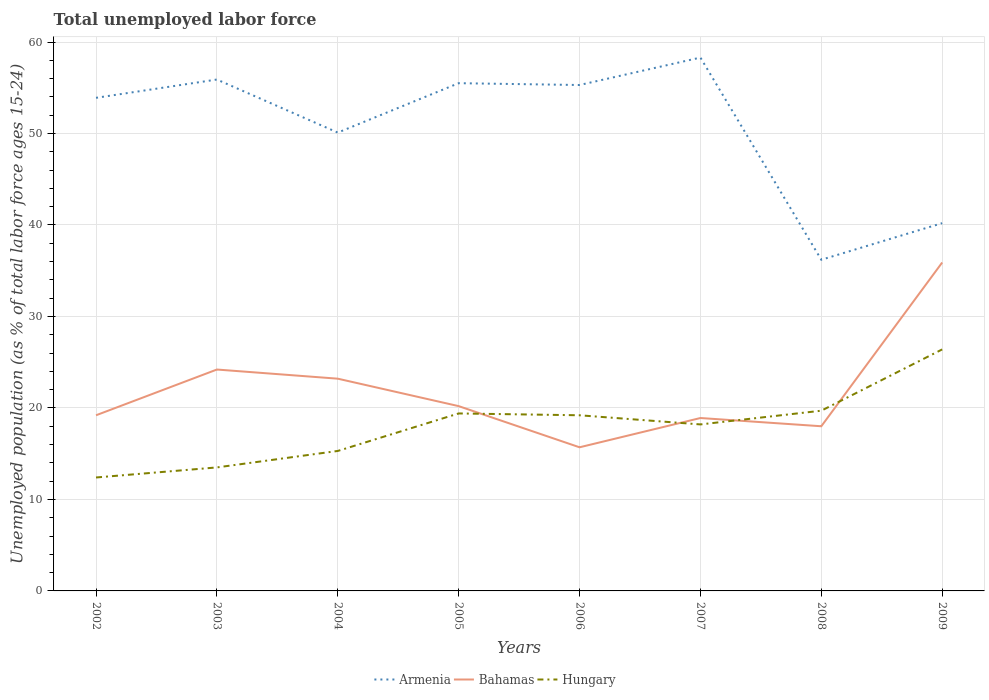Does the line corresponding to Armenia intersect with the line corresponding to Bahamas?
Keep it short and to the point. No. Is the number of lines equal to the number of legend labels?
Your answer should be very brief. Yes. Across all years, what is the maximum percentage of unemployed population in in Armenia?
Provide a succinct answer. 36.2. In which year was the percentage of unemployed population in in Bahamas maximum?
Offer a terse response. 2006. What is the total percentage of unemployed population in in Armenia in the graph?
Provide a succinct answer. -2.8. What is the difference between the highest and the second highest percentage of unemployed population in in Bahamas?
Make the answer very short. 20.2. Is the percentage of unemployed population in in Hungary strictly greater than the percentage of unemployed population in in Armenia over the years?
Make the answer very short. Yes. How many lines are there?
Your answer should be very brief. 3. What is the difference between two consecutive major ticks on the Y-axis?
Your answer should be compact. 10. Are the values on the major ticks of Y-axis written in scientific E-notation?
Offer a terse response. No. Does the graph contain any zero values?
Your answer should be very brief. No. Does the graph contain grids?
Your answer should be very brief. Yes. Where does the legend appear in the graph?
Provide a succinct answer. Bottom center. What is the title of the graph?
Your answer should be very brief. Total unemployed labor force. Does "Estonia" appear as one of the legend labels in the graph?
Provide a succinct answer. No. What is the label or title of the Y-axis?
Keep it short and to the point. Unemployed population (as % of total labor force ages 15-24). What is the Unemployed population (as % of total labor force ages 15-24) in Armenia in 2002?
Offer a very short reply. 53.9. What is the Unemployed population (as % of total labor force ages 15-24) of Bahamas in 2002?
Give a very brief answer. 19.2. What is the Unemployed population (as % of total labor force ages 15-24) in Hungary in 2002?
Ensure brevity in your answer.  12.4. What is the Unemployed population (as % of total labor force ages 15-24) of Armenia in 2003?
Keep it short and to the point. 55.9. What is the Unemployed population (as % of total labor force ages 15-24) in Bahamas in 2003?
Give a very brief answer. 24.2. What is the Unemployed population (as % of total labor force ages 15-24) of Hungary in 2003?
Provide a short and direct response. 13.5. What is the Unemployed population (as % of total labor force ages 15-24) in Armenia in 2004?
Provide a succinct answer. 50.1. What is the Unemployed population (as % of total labor force ages 15-24) of Bahamas in 2004?
Offer a terse response. 23.2. What is the Unemployed population (as % of total labor force ages 15-24) of Hungary in 2004?
Your response must be concise. 15.3. What is the Unemployed population (as % of total labor force ages 15-24) in Armenia in 2005?
Make the answer very short. 55.5. What is the Unemployed population (as % of total labor force ages 15-24) of Bahamas in 2005?
Your answer should be compact. 20.2. What is the Unemployed population (as % of total labor force ages 15-24) in Hungary in 2005?
Your answer should be very brief. 19.4. What is the Unemployed population (as % of total labor force ages 15-24) in Armenia in 2006?
Keep it short and to the point. 55.3. What is the Unemployed population (as % of total labor force ages 15-24) in Bahamas in 2006?
Provide a succinct answer. 15.7. What is the Unemployed population (as % of total labor force ages 15-24) in Hungary in 2006?
Provide a short and direct response. 19.2. What is the Unemployed population (as % of total labor force ages 15-24) in Armenia in 2007?
Your response must be concise. 58.3. What is the Unemployed population (as % of total labor force ages 15-24) in Bahamas in 2007?
Provide a succinct answer. 18.9. What is the Unemployed population (as % of total labor force ages 15-24) of Hungary in 2007?
Provide a short and direct response. 18.2. What is the Unemployed population (as % of total labor force ages 15-24) in Armenia in 2008?
Make the answer very short. 36.2. What is the Unemployed population (as % of total labor force ages 15-24) in Hungary in 2008?
Your answer should be very brief. 19.7. What is the Unemployed population (as % of total labor force ages 15-24) in Armenia in 2009?
Offer a very short reply. 40.2. What is the Unemployed population (as % of total labor force ages 15-24) of Bahamas in 2009?
Your response must be concise. 35.9. What is the Unemployed population (as % of total labor force ages 15-24) of Hungary in 2009?
Your answer should be very brief. 26.4. Across all years, what is the maximum Unemployed population (as % of total labor force ages 15-24) of Armenia?
Provide a succinct answer. 58.3. Across all years, what is the maximum Unemployed population (as % of total labor force ages 15-24) in Bahamas?
Keep it short and to the point. 35.9. Across all years, what is the maximum Unemployed population (as % of total labor force ages 15-24) in Hungary?
Provide a short and direct response. 26.4. Across all years, what is the minimum Unemployed population (as % of total labor force ages 15-24) in Armenia?
Offer a terse response. 36.2. Across all years, what is the minimum Unemployed population (as % of total labor force ages 15-24) in Bahamas?
Offer a terse response. 15.7. Across all years, what is the minimum Unemployed population (as % of total labor force ages 15-24) of Hungary?
Offer a very short reply. 12.4. What is the total Unemployed population (as % of total labor force ages 15-24) of Armenia in the graph?
Your answer should be compact. 405.4. What is the total Unemployed population (as % of total labor force ages 15-24) in Bahamas in the graph?
Keep it short and to the point. 175.3. What is the total Unemployed population (as % of total labor force ages 15-24) in Hungary in the graph?
Keep it short and to the point. 144.1. What is the difference between the Unemployed population (as % of total labor force ages 15-24) in Armenia in 2002 and that in 2003?
Provide a succinct answer. -2. What is the difference between the Unemployed population (as % of total labor force ages 15-24) in Hungary in 2002 and that in 2003?
Make the answer very short. -1.1. What is the difference between the Unemployed population (as % of total labor force ages 15-24) of Bahamas in 2002 and that in 2004?
Make the answer very short. -4. What is the difference between the Unemployed population (as % of total labor force ages 15-24) in Hungary in 2002 and that in 2004?
Provide a succinct answer. -2.9. What is the difference between the Unemployed population (as % of total labor force ages 15-24) of Armenia in 2002 and that in 2005?
Your answer should be compact. -1.6. What is the difference between the Unemployed population (as % of total labor force ages 15-24) of Hungary in 2002 and that in 2005?
Make the answer very short. -7. What is the difference between the Unemployed population (as % of total labor force ages 15-24) in Armenia in 2002 and that in 2006?
Give a very brief answer. -1.4. What is the difference between the Unemployed population (as % of total labor force ages 15-24) in Bahamas in 2002 and that in 2006?
Provide a succinct answer. 3.5. What is the difference between the Unemployed population (as % of total labor force ages 15-24) of Armenia in 2002 and that in 2007?
Your answer should be compact. -4.4. What is the difference between the Unemployed population (as % of total labor force ages 15-24) in Hungary in 2002 and that in 2007?
Offer a terse response. -5.8. What is the difference between the Unemployed population (as % of total labor force ages 15-24) in Hungary in 2002 and that in 2008?
Your answer should be very brief. -7.3. What is the difference between the Unemployed population (as % of total labor force ages 15-24) in Armenia in 2002 and that in 2009?
Provide a succinct answer. 13.7. What is the difference between the Unemployed population (as % of total labor force ages 15-24) of Bahamas in 2002 and that in 2009?
Ensure brevity in your answer.  -16.7. What is the difference between the Unemployed population (as % of total labor force ages 15-24) of Bahamas in 2003 and that in 2004?
Provide a short and direct response. 1. What is the difference between the Unemployed population (as % of total labor force ages 15-24) in Hungary in 2003 and that in 2004?
Give a very brief answer. -1.8. What is the difference between the Unemployed population (as % of total labor force ages 15-24) of Hungary in 2003 and that in 2005?
Your answer should be very brief. -5.9. What is the difference between the Unemployed population (as % of total labor force ages 15-24) in Armenia in 2003 and that in 2006?
Provide a short and direct response. 0.6. What is the difference between the Unemployed population (as % of total labor force ages 15-24) of Armenia in 2003 and that in 2007?
Your answer should be compact. -2.4. What is the difference between the Unemployed population (as % of total labor force ages 15-24) of Hungary in 2003 and that in 2007?
Offer a very short reply. -4.7. What is the difference between the Unemployed population (as % of total labor force ages 15-24) of Armenia in 2003 and that in 2008?
Provide a succinct answer. 19.7. What is the difference between the Unemployed population (as % of total labor force ages 15-24) in Armenia in 2004 and that in 2005?
Ensure brevity in your answer.  -5.4. What is the difference between the Unemployed population (as % of total labor force ages 15-24) in Armenia in 2004 and that in 2006?
Make the answer very short. -5.2. What is the difference between the Unemployed population (as % of total labor force ages 15-24) in Armenia in 2004 and that in 2007?
Your answer should be compact. -8.2. What is the difference between the Unemployed population (as % of total labor force ages 15-24) in Hungary in 2004 and that in 2007?
Keep it short and to the point. -2.9. What is the difference between the Unemployed population (as % of total labor force ages 15-24) of Hungary in 2004 and that in 2008?
Ensure brevity in your answer.  -4.4. What is the difference between the Unemployed population (as % of total labor force ages 15-24) in Armenia in 2004 and that in 2009?
Offer a very short reply. 9.9. What is the difference between the Unemployed population (as % of total labor force ages 15-24) in Hungary in 2004 and that in 2009?
Your answer should be very brief. -11.1. What is the difference between the Unemployed population (as % of total labor force ages 15-24) in Armenia in 2005 and that in 2006?
Provide a short and direct response. 0.2. What is the difference between the Unemployed population (as % of total labor force ages 15-24) of Bahamas in 2005 and that in 2006?
Make the answer very short. 4.5. What is the difference between the Unemployed population (as % of total labor force ages 15-24) of Hungary in 2005 and that in 2006?
Your answer should be compact. 0.2. What is the difference between the Unemployed population (as % of total labor force ages 15-24) of Armenia in 2005 and that in 2007?
Make the answer very short. -2.8. What is the difference between the Unemployed population (as % of total labor force ages 15-24) of Hungary in 2005 and that in 2007?
Give a very brief answer. 1.2. What is the difference between the Unemployed population (as % of total labor force ages 15-24) in Armenia in 2005 and that in 2008?
Keep it short and to the point. 19.3. What is the difference between the Unemployed population (as % of total labor force ages 15-24) in Hungary in 2005 and that in 2008?
Your answer should be compact. -0.3. What is the difference between the Unemployed population (as % of total labor force ages 15-24) in Armenia in 2005 and that in 2009?
Make the answer very short. 15.3. What is the difference between the Unemployed population (as % of total labor force ages 15-24) of Bahamas in 2005 and that in 2009?
Keep it short and to the point. -15.7. What is the difference between the Unemployed population (as % of total labor force ages 15-24) in Bahamas in 2006 and that in 2007?
Keep it short and to the point. -3.2. What is the difference between the Unemployed population (as % of total labor force ages 15-24) in Bahamas in 2006 and that in 2008?
Your response must be concise. -2.3. What is the difference between the Unemployed population (as % of total labor force ages 15-24) of Armenia in 2006 and that in 2009?
Provide a short and direct response. 15.1. What is the difference between the Unemployed population (as % of total labor force ages 15-24) of Bahamas in 2006 and that in 2009?
Ensure brevity in your answer.  -20.2. What is the difference between the Unemployed population (as % of total labor force ages 15-24) of Armenia in 2007 and that in 2008?
Provide a succinct answer. 22.1. What is the difference between the Unemployed population (as % of total labor force ages 15-24) in Hungary in 2007 and that in 2008?
Your answer should be very brief. -1.5. What is the difference between the Unemployed population (as % of total labor force ages 15-24) in Armenia in 2007 and that in 2009?
Ensure brevity in your answer.  18.1. What is the difference between the Unemployed population (as % of total labor force ages 15-24) of Hungary in 2007 and that in 2009?
Offer a very short reply. -8.2. What is the difference between the Unemployed population (as % of total labor force ages 15-24) in Armenia in 2008 and that in 2009?
Your answer should be very brief. -4. What is the difference between the Unemployed population (as % of total labor force ages 15-24) of Bahamas in 2008 and that in 2009?
Keep it short and to the point. -17.9. What is the difference between the Unemployed population (as % of total labor force ages 15-24) in Hungary in 2008 and that in 2009?
Make the answer very short. -6.7. What is the difference between the Unemployed population (as % of total labor force ages 15-24) in Armenia in 2002 and the Unemployed population (as % of total labor force ages 15-24) in Bahamas in 2003?
Give a very brief answer. 29.7. What is the difference between the Unemployed population (as % of total labor force ages 15-24) of Armenia in 2002 and the Unemployed population (as % of total labor force ages 15-24) of Hungary in 2003?
Provide a short and direct response. 40.4. What is the difference between the Unemployed population (as % of total labor force ages 15-24) in Armenia in 2002 and the Unemployed population (as % of total labor force ages 15-24) in Bahamas in 2004?
Provide a short and direct response. 30.7. What is the difference between the Unemployed population (as % of total labor force ages 15-24) in Armenia in 2002 and the Unemployed population (as % of total labor force ages 15-24) in Hungary in 2004?
Provide a short and direct response. 38.6. What is the difference between the Unemployed population (as % of total labor force ages 15-24) of Armenia in 2002 and the Unemployed population (as % of total labor force ages 15-24) of Bahamas in 2005?
Keep it short and to the point. 33.7. What is the difference between the Unemployed population (as % of total labor force ages 15-24) of Armenia in 2002 and the Unemployed population (as % of total labor force ages 15-24) of Hungary in 2005?
Ensure brevity in your answer.  34.5. What is the difference between the Unemployed population (as % of total labor force ages 15-24) in Bahamas in 2002 and the Unemployed population (as % of total labor force ages 15-24) in Hungary in 2005?
Your answer should be very brief. -0.2. What is the difference between the Unemployed population (as % of total labor force ages 15-24) of Armenia in 2002 and the Unemployed population (as % of total labor force ages 15-24) of Bahamas in 2006?
Provide a succinct answer. 38.2. What is the difference between the Unemployed population (as % of total labor force ages 15-24) in Armenia in 2002 and the Unemployed population (as % of total labor force ages 15-24) in Hungary in 2006?
Provide a succinct answer. 34.7. What is the difference between the Unemployed population (as % of total labor force ages 15-24) in Bahamas in 2002 and the Unemployed population (as % of total labor force ages 15-24) in Hungary in 2006?
Your answer should be compact. 0. What is the difference between the Unemployed population (as % of total labor force ages 15-24) of Armenia in 2002 and the Unemployed population (as % of total labor force ages 15-24) of Hungary in 2007?
Ensure brevity in your answer.  35.7. What is the difference between the Unemployed population (as % of total labor force ages 15-24) of Bahamas in 2002 and the Unemployed population (as % of total labor force ages 15-24) of Hungary in 2007?
Keep it short and to the point. 1. What is the difference between the Unemployed population (as % of total labor force ages 15-24) in Armenia in 2002 and the Unemployed population (as % of total labor force ages 15-24) in Bahamas in 2008?
Make the answer very short. 35.9. What is the difference between the Unemployed population (as % of total labor force ages 15-24) of Armenia in 2002 and the Unemployed population (as % of total labor force ages 15-24) of Hungary in 2008?
Your response must be concise. 34.2. What is the difference between the Unemployed population (as % of total labor force ages 15-24) of Armenia in 2002 and the Unemployed population (as % of total labor force ages 15-24) of Bahamas in 2009?
Provide a succinct answer. 18. What is the difference between the Unemployed population (as % of total labor force ages 15-24) of Bahamas in 2002 and the Unemployed population (as % of total labor force ages 15-24) of Hungary in 2009?
Your response must be concise. -7.2. What is the difference between the Unemployed population (as % of total labor force ages 15-24) of Armenia in 2003 and the Unemployed population (as % of total labor force ages 15-24) of Bahamas in 2004?
Provide a succinct answer. 32.7. What is the difference between the Unemployed population (as % of total labor force ages 15-24) of Armenia in 2003 and the Unemployed population (as % of total labor force ages 15-24) of Hungary in 2004?
Ensure brevity in your answer.  40.6. What is the difference between the Unemployed population (as % of total labor force ages 15-24) in Armenia in 2003 and the Unemployed population (as % of total labor force ages 15-24) in Bahamas in 2005?
Provide a succinct answer. 35.7. What is the difference between the Unemployed population (as % of total labor force ages 15-24) of Armenia in 2003 and the Unemployed population (as % of total labor force ages 15-24) of Hungary in 2005?
Keep it short and to the point. 36.5. What is the difference between the Unemployed population (as % of total labor force ages 15-24) in Bahamas in 2003 and the Unemployed population (as % of total labor force ages 15-24) in Hungary in 2005?
Provide a succinct answer. 4.8. What is the difference between the Unemployed population (as % of total labor force ages 15-24) of Armenia in 2003 and the Unemployed population (as % of total labor force ages 15-24) of Bahamas in 2006?
Offer a very short reply. 40.2. What is the difference between the Unemployed population (as % of total labor force ages 15-24) of Armenia in 2003 and the Unemployed population (as % of total labor force ages 15-24) of Hungary in 2006?
Offer a very short reply. 36.7. What is the difference between the Unemployed population (as % of total labor force ages 15-24) of Bahamas in 2003 and the Unemployed population (as % of total labor force ages 15-24) of Hungary in 2006?
Your answer should be very brief. 5. What is the difference between the Unemployed population (as % of total labor force ages 15-24) of Armenia in 2003 and the Unemployed population (as % of total labor force ages 15-24) of Bahamas in 2007?
Give a very brief answer. 37. What is the difference between the Unemployed population (as % of total labor force ages 15-24) in Armenia in 2003 and the Unemployed population (as % of total labor force ages 15-24) in Hungary in 2007?
Ensure brevity in your answer.  37.7. What is the difference between the Unemployed population (as % of total labor force ages 15-24) in Bahamas in 2003 and the Unemployed population (as % of total labor force ages 15-24) in Hungary in 2007?
Offer a very short reply. 6. What is the difference between the Unemployed population (as % of total labor force ages 15-24) of Armenia in 2003 and the Unemployed population (as % of total labor force ages 15-24) of Bahamas in 2008?
Make the answer very short. 37.9. What is the difference between the Unemployed population (as % of total labor force ages 15-24) in Armenia in 2003 and the Unemployed population (as % of total labor force ages 15-24) in Hungary in 2008?
Offer a very short reply. 36.2. What is the difference between the Unemployed population (as % of total labor force ages 15-24) of Armenia in 2003 and the Unemployed population (as % of total labor force ages 15-24) of Hungary in 2009?
Offer a terse response. 29.5. What is the difference between the Unemployed population (as % of total labor force ages 15-24) of Bahamas in 2003 and the Unemployed population (as % of total labor force ages 15-24) of Hungary in 2009?
Provide a short and direct response. -2.2. What is the difference between the Unemployed population (as % of total labor force ages 15-24) in Armenia in 2004 and the Unemployed population (as % of total labor force ages 15-24) in Bahamas in 2005?
Offer a terse response. 29.9. What is the difference between the Unemployed population (as % of total labor force ages 15-24) in Armenia in 2004 and the Unemployed population (as % of total labor force ages 15-24) in Hungary in 2005?
Your answer should be compact. 30.7. What is the difference between the Unemployed population (as % of total labor force ages 15-24) of Armenia in 2004 and the Unemployed population (as % of total labor force ages 15-24) of Bahamas in 2006?
Your response must be concise. 34.4. What is the difference between the Unemployed population (as % of total labor force ages 15-24) in Armenia in 2004 and the Unemployed population (as % of total labor force ages 15-24) in Hungary in 2006?
Provide a succinct answer. 30.9. What is the difference between the Unemployed population (as % of total labor force ages 15-24) of Armenia in 2004 and the Unemployed population (as % of total labor force ages 15-24) of Bahamas in 2007?
Your response must be concise. 31.2. What is the difference between the Unemployed population (as % of total labor force ages 15-24) in Armenia in 2004 and the Unemployed population (as % of total labor force ages 15-24) in Hungary in 2007?
Offer a very short reply. 31.9. What is the difference between the Unemployed population (as % of total labor force ages 15-24) of Armenia in 2004 and the Unemployed population (as % of total labor force ages 15-24) of Bahamas in 2008?
Give a very brief answer. 32.1. What is the difference between the Unemployed population (as % of total labor force ages 15-24) of Armenia in 2004 and the Unemployed population (as % of total labor force ages 15-24) of Hungary in 2008?
Your response must be concise. 30.4. What is the difference between the Unemployed population (as % of total labor force ages 15-24) in Bahamas in 2004 and the Unemployed population (as % of total labor force ages 15-24) in Hungary in 2008?
Offer a very short reply. 3.5. What is the difference between the Unemployed population (as % of total labor force ages 15-24) of Armenia in 2004 and the Unemployed population (as % of total labor force ages 15-24) of Bahamas in 2009?
Offer a terse response. 14.2. What is the difference between the Unemployed population (as % of total labor force ages 15-24) of Armenia in 2004 and the Unemployed population (as % of total labor force ages 15-24) of Hungary in 2009?
Keep it short and to the point. 23.7. What is the difference between the Unemployed population (as % of total labor force ages 15-24) of Bahamas in 2004 and the Unemployed population (as % of total labor force ages 15-24) of Hungary in 2009?
Give a very brief answer. -3.2. What is the difference between the Unemployed population (as % of total labor force ages 15-24) in Armenia in 2005 and the Unemployed population (as % of total labor force ages 15-24) in Bahamas in 2006?
Give a very brief answer. 39.8. What is the difference between the Unemployed population (as % of total labor force ages 15-24) in Armenia in 2005 and the Unemployed population (as % of total labor force ages 15-24) in Hungary in 2006?
Keep it short and to the point. 36.3. What is the difference between the Unemployed population (as % of total labor force ages 15-24) of Bahamas in 2005 and the Unemployed population (as % of total labor force ages 15-24) of Hungary in 2006?
Keep it short and to the point. 1. What is the difference between the Unemployed population (as % of total labor force ages 15-24) in Armenia in 2005 and the Unemployed population (as % of total labor force ages 15-24) in Bahamas in 2007?
Give a very brief answer. 36.6. What is the difference between the Unemployed population (as % of total labor force ages 15-24) in Armenia in 2005 and the Unemployed population (as % of total labor force ages 15-24) in Hungary in 2007?
Provide a short and direct response. 37.3. What is the difference between the Unemployed population (as % of total labor force ages 15-24) in Armenia in 2005 and the Unemployed population (as % of total labor force ages 15-24) in Bahamas in 2008?
Keep it short and to the point. 37.5. What is the difference between the Unemployed population (as % of total labor force ages 15-24) of Armenia in 2005 and the Unemployed population (as % of total labor force ages 15-24) of Hungary in 2008?
Your answer should be very brief. 35.8. What is the difference between the Unemployed population (as % of total labor force ages 15-24) of Armenia in 2005 and the Unemployed population (as % of total labor force ages 15-24) of Bahamas in 2009?
Give a very brief answer. 19.6. What is the difference between the Unemployed population (as % of total labor force ages 15-24) in Armenia in 2005 and the Unemployed population (as % of total labor force ages 15-24) in Hungary in 2009?
Your answer should be compact. 29.1. What is the difference between the Unemployed population (as % of total labor force ages 15-24) in Armenia in 2006 and the Unemployed population (as % of total labor force ages 15-24) in Bahamas in 2007?
Give a very brief answer. 36.4. What is the difference between the Unemployed population (as % of total labor force ages 15-24) of Armenia in 2006 and the Unemployed population (as % of total labor force ages 15-24) of Hungary in 2007?
Your answer should be very brief. 37.1. What is the difference between the Unemployed population (as % of total labor force ages 15-24) in Bahamas in 2006 and the Unemployed population (as % of total labor force ages 15-24) in Hungary in 2007?
Provide a succinct answer. -2.5. What is the difference between the Unemployed population (as % of total labor force ages 15-24) in Armenia in 2006 and the Unemployed population (as % of total labor force ages 15-24) in Bahamas in 2008?
Your answer should be very brief. 37.3. What is the difference between the Unemployed population (as % of total labor force ages 15-24) of Armenia in 2006 and the Unemployed population (as % of total labor force ages 15-24) of Hungary in 2008?
Provide a short and direct response. 35.6. What is the difference between the Unemployed population (as % of total labor force ages 15-24) of Armenia in 2006 and the Unemployed population (as % of total labor force ages 15-24) of Hungary in 2009?
Your answer should be very brief. 28.9. What is the difference between the Unemployed population (as % of total labor force ages 15-24) of Armenia in 2007 and the Unemployed population (as % of total labor force ages 15-24) of Bahamas in 2008?
Offer a very short reply. 40.3. What is the difference between the Unemployed population (as % of total labor force ages 15-24) of Armenia in 2007 and the Unemployed population (as % of total labor force ages 15-24) of Hungary in 2008?
Provide a succinct answer. 38.6. What is the difference between the Unemployed population (as % of total labor force ages 15-24) of Bahamas in 2007 and the Unemployed population (as % of total labor force ages 15-24) of Hungary in 2008?
Your answer should be very brief. -0.8. What is the difference between the Unemployed population (as % of total labor force ages 15-24) in Armenia in 2007 and the Unemployed population (as % of total labor force ages 15-24) in Bahamas in 2009?
Give a very brief answer. 22.4. What is the difference between the Unemployed population (as % of total labor force ages 15-24) of Armenia in 2007 and the Unemployed population (as % of total labor force ages 15-24) of Hungary in 2009?
Make the answer very short. 31.9. What is the difference between the Unemployed population (as % of total labor force ages 15-24) in Armenia in 2008 and the Unemployed population (as % of total labor force ages 15-24) in Bahamas in 2009?
Keep it short and to the point. 0.3. What is the average Unemployed population (as % of total labor force ages 15-24) in Armenia per year?
Keep it short and to the point. 50.67. What is the average Unemployed population (as % of total labor force ages 15-24) of Bahamas per year?
Your response must be concise. 21.91. What is the average Unemployed population (as % of total labor force ages 15-24) in Hungary per year?
Offer a terse response. 18.01. In the year 2002, what is the difference between the Unemployed population (as % of total labor force ages 15-24) of Armenia and Unemployed population (as % of total labor force ages 15-24) of Bahamas?
Provide a short and direct response. 34.7. In the year 2002, what is the difference between the Unemployed population (as % of total labor force ages 15-24) in Armenia and Unemployed population (as % of total labor force ages 15-24) in Hungary?
Your answer should be very brief. 41.5. In the year 2003, what is the difference between the Unemployed population (as % of total labor force ages 15-24) of Armenia and Unemployed population (as % of total labor force ages 15-24) of Bahamas?
Your answer should be compact. 31.7. In the year 2003, what is the difference between the Unemployed population (as % of total labor force ages 15-24) in Armenia and Unemployed population (as % of total labor force ages 15-24) in Hungary?
Provide a short and direct response. 42.4. In the year 2003, what is the difference between the Unemployed population (as % of total labor force ages 15-24) in Bahamas and Unemployed population (as % of total labor force ages 15-24) in Hungary?
Ensure brevity in your answer.  10.7. In the year 2004, what is the difference between the Unemployed population (as % of total labor force ages 15-24) in Armenia and Unemployed population (as % of total labor force ages 15-24) in Bahamas?
Ensure brevity in your answer.  26.9. In the year 2004, what is the difference between the Unemployed population (as % of total labor force ages 15-24) of Armenia and Unemployed population (as % of total labor force ages 15-24) of Hungary?
Provide a short and direct response. 34.8. In the year 2004, what is the difference between the Unemployed population (as % of total labor force ages 15-24) of Bahamas and Unemployed population (as % of total labor force ages 15-24) of Hungary?
Your answer should be compact. 7.9. In the year 2005, what is the difference between the Unemployed population (as % of total labor force ages 15-24) in Armenia and Unemployed population (as % of total labor force ages 15-24) in Bahamas?
Give a very brief answer. 35.3. In the year 2005, what is the difference between the Unemployed population (as % of total labor force ages 15-24) of Armenia and Unemployed population (as % of total labor force ages 15-24) of Hungary?
Your answer should be very brief. 36.1. In the year 2006, what is the difference between the Unemployed population (as % of total labor force ages 15-24) of Armenia and Unemployed population (as % of total labor force ages 15-24) of Bahamas?
Your answer should be very brief. 39.6. In the year 2006, what is the difference between the Unemployed population (as % of total labor force ages 15-24) in Armenia and Unemployed population (as % of total labor force ages 15-24) in Hungary?
Ensure brevity in your answer.  36.1. In the year 2006, what is the difference between the Unemployed population (as % of total labor force ages 15-24) in Bahamas and Unemployed population (as % of total labor force ages 15-24) in Hungary?
Keep it short and to the point. -3.5. In the year 2007, what is the difference between the Unemployed population (as % of total labor force ages 15-24) in Armenia and Unemployed population (as % of total labor force ages 15-24) in Bahamas?
Your answer should be compact. 39.4. In the year 2007, what is the difference between the Unemployed population (as % of total labor force ages 15-24) in Armenia and Unemployed population (as % of total labor force ages 15-24) in Hungary?
Your response must be concise. 40.1. In the year 2007, what is the difference between the Unemployed population (as % of total labor force ages 15-24) of Bahamas and Unemployed population (as % of total labor force ages 15-24) of Hungary?
Give a very brief answer. 0.7. In the year 2008, what is the difference between the Unemployed population (as % of total labor force ages 15-24) in Armenia and Unemployed population (as % of total labor force ages 15-24) in Bahamas?
Your response must be concise. 18.2. In the year 2008, what is the difference between the Unemployed population (as % of total labor force ages 15-24) in Bahamas and Unemployed population (as % of total labor force ages 15-24) in Hungary?
Keep it short and to the point. -1.7. In the year 2009, what is the difference between the Unemployed population (as % of total labor force ages 15-24) of Bahamas and Unemployed population (as % of total labor force ages 15-24) of Hungary?
Keep it short and to the point. 9.5. What is the ratio of the Unemployed population (as % of total labor force ages 15-24) in Armenia in 2002 to that in 2003?
Offer a very short reply. 0.96. What is the ratio of the Unemployed population (as % of total labor force ages 15-24) in Bahamas in 2002 to that in 2003?
Offer a terse response. 0.79. What is the ratio of the Unemployed population (as % of total labor force ages 15-24) of Hungary in 2002 to that in 2003?
Make the answer very short. 0.92. What is the ratio of the Unemployed population (as % of total labor force ages 15-24) in Armenia in 2002 to that in 2004?
Give a very brief answer. 1.08. What is the ratio of the Unemployed population (as % of total labor force ages 15-24) in Bahamas in 2002 to that in 2004?
Your answer should be compact. 0.83. What is the ratio of the Unemployed population (as % of total labor force ages 15-24) of Hungary in 2002 to that in 2004?
Offer a terse response. 0.81. What is the ratio of the Unemployed population (as % of total labor force ages 15-24) in Armenia in 2002 to that in 2005?
Your answer should be compact. 0.97. What is the ratio of the Unemployed population (as % of total labor force ages 15-24) of Bahamas in 2002 to that in 2005?
Keep it short and to the point. 0.95. What is the ratio of the Unemployed population (as % of total labor force ages 15-24) in Hungary in 2002 to that in 2005?
Offer a terse response. 0.64. What is the ratio of the Unemployed population (as % of total labor force ages 15-24) in Armenia in 2002 to that in 2006?
Provide a short and direct response. 0.97. What is the ratio of the Unemployed population (as % of total labor force ages 15-24) of Bahamas in 2002 to that in 2006?
Your response must be concise. 1.22. What is the ratio of the Unemployed population (as % of total labor force ages 15-24) in Hungary in 2002 to that in 2006?
Offer a very short reply. 0.65. What is the ratio of the Unemployed population (as % of total labor force ages 15-24) in Armenia in 2002 to that in 2007?
Keep it short and to the point. 0.92. What is the ratio of the Unemployed population (as % of total labor force ages 15-24) in Bahamas in 2002 to that in 2007?
Give a very brief answer. 1.02. What is the ratio of the Unemployed population (as % of total labor force ages 15-24) of Hungary in 2002 to that in 2007?
Provide a short and direct response. 0.68. What is the ratio of the Unemployed population (as % of total labor force ages 15-24) in Armenia in 2002 to that in 2008?
Make the answer very short. 1.49. What is the ratio of the Unemployed population (as % of total labor force ages 15-24) of Bahamas in 2002 to that in 2008?
Offer a very short reply. 1.07. What is the ratio of the Unemployed population (as % of total labor force ages 15-24) of Hungary in 2002 to that in 2008?
Keep it short and to the point. 0.63. What is the ratio of the Unemployed population (as % of total labor force ages 15-24) of Armenia in 2002 to that in 2009?
Offer a very short reply. 1.34. What is the ratio of the Unemployed population (as % of total labor force ages 15-24) of Bahamas in 2002 to that in 2009?
Your response must be concise. 0.53. What is the ratio of the Unemployed population (as % of total labor force ages 15-24) in Hungary in 2002 to that in 2009?
Offer a terse response. 0.47. What is the ratio of the Unemployed population (as % of total labor force ages 15-24) of Armenia in 2003 to that in 2004?
Your answer should be very brief. 1.12. What is the ratio of the Unemployed population (as % of total labor force ages 15-24) of Bahamas in 2003 to that in 2004?
Provide a succinct answer. 1.04. What is the ratio of the Unemployed population (as % of total labor force ages 15-24) of Hungary in 2003 to that in 2004?
Your answer should be compact. 0.88. What is the ratio of the Unemployed population (as % of total labor force ages 15-24) of Armenia in 2003 to that in 2005?
Keep it short and to the point. 1.01. What is the ratio of the Unemployed population (as % of total labor force ages 15-24) of Bahamas in 2003 to that in 2005?
Make the answer very short. 1.2. What is the ratio of the Unemployed population (as % of total labor force ages 15-24) in Hungary in 2003 to that in 2005?
Your answer should be compact. 0.7. What is the ratio of the Unemployed population (as % of total labor force ages 15-24) of Armenia in 2003 to that in 2006?
Provide a succinct answer. 1.01. What is the ratio of the Unemployed population (as % of total labor force ages 15-24) of Bahamas in 2003 to that in 2006?
Provide a succinct answer. 1.54. What is the ratio of the Unemployed population (as % of total labor force ages 15-24) of Hungary in 2003 to that in 2006?
Provide a short and direct response. 0.7. What is the ratio of the Unemployed population (as % of total labor force ages 15-24) of Armenia in 2003 to that in 2007?
Ensure brevity in your answer.  0.96. What is the ratio of the Unemployed population (as % of total labor force ages 15-24) in Bahamas in 2003 to that in 2007?
Ensure brevity in your answer.  1.28. What is the ratio of the Unemployed population (as % of total labor force ages 15-24) of Hungary in 2003 to that in 2007?
Give a very brief answer. 0.74. What is the ratio of the Unemployed population (as % of total labor force ages 15-24) in Armenia in 2003 to that in 2008?
Offer a terse response. 1.54. What is the ratio of the Unemployed population (as % of total labor force ages 15-24) in Bahamas in 2003 to that in 2008?
Offer a terse response. 1.34. What is the ratio of the Unemployed population (as % of total labor force ages 15-24) of Hungary in 2003 to that in 2008?
Your answer should be very brief. 0.69. What is the ratio of the Unemployed population (as % of total labor force ages 15-24) of Armenia in 2003 to that in 2009?
Provide a succinct answer. 1.39. What is the ratio of the Unemployed population (as % of total labor force ages 15-24) in Bahamas in 2003 to that in 2009?
Your answer should be compact. 0.67. What is the ratio of the Unemployed population (as % of total labor force ages 15-24) in Hungary in 2003 to that in 2009?
Your answer should be very brief. 0.51. What is the ratio of the Unemployed population (as % of total labor force ages 15-24) in Armenia in 2004 to that in 2005?
Make the answer very short. 0.9. What is the ratio of the Unemployed population (as % of total labor force ages 15-24) of Bahamas in 2004 to that in 2005?
Your answer should be very brief. 1.15. What is the ratio of the Unemployed population (as % of total labor force ages 15-24) in Hungary in 2004 to that in 2005?
Make the answer very short. 0.79. What is the ratio of the Unemployed population (as % of total labor force ages 15-24) in Armenia in 2004 to that in 2006?
Your response must be concise. 0.91. What is the ratio of the Unemployed population (as % of total labor force ages 15-24) of Bahamas in 2004 to that in 2006?
Your response must be concise. 1.48. What is the ratio of the Unemployed population (as % of total labor force ages 15-24) of Hungary in 2004 to that in 2006?
Your response must be concise. 0.8. What is the ratio of the Unemployed population (as % of total labor force ages 15-24) in Armenia in 2004 to that in 2007?
Keep it short and to the point. 0.86. What is the ratio of the Unemployed population (as % of total labor force ages 15-24) in Bahamas in 2004 to that in 2007?
Keep it short and to the point. 1.23. What is the ratio of the Unemployed population (as % of total labor force ages 15-24) in Hungary in 2004 to that in 2007?
Offer a terse response. 0.84. What is the ratio of the Unemployed population (as % of total labor force ages 15-24) of Armenia in 2004 to that in 2008?
Offer a terse response. 1.38. What is the ratio of the Unemployed population (as % of total labor force ages 15-24) in Bahamas in 2004 to that in 2008?
Provide a short and direct response. 1.29. What is the ratio of the Unemployed population (as % of total labor force ages 15-24) in Hungary in 2004 to that in 2008?
Offer a terse response. 0.78. What is the ratio of the Unemployed population (as % of total labor force ages 15-24) in Armenia in 2004 to that in 2009?
Your answer should be compact. 1.25. What is the ratio of the Unemployed population (as % of total labor force ages 15-24) in Bahamas in 2004 to that in 2009?
Give a very brief answer. 0.65. What is the ratio of the Unemployed population (as % of total labor force ages 15-24) in Hungary in 2004 to that in 2009?
Provide a succinct answer. 0.58. What is the ratio of the Unemployed population (as % of total labor force ages 15-24) of Armenia in 2005 to that in 2006?
Your response must be concise. 1. What is the ratio of the Unemployed population (as % of total labor force ages 15-24) of Bahamas in 2005 to that in 2006?
Ensure brevity in your answer.  1.29. What is the ratio of the Unemployed population (as % of total labor force ages 15-24) of Hungary in 2005 to that in 2006?
Make the answer very short. 1.01. What is the ratio of the Unemployed population (as % of total labor force ages 15-24) of Bahamas in 2005 to that in 2007?
Your answer should be compact. 1.07. What is the ratio of the Unemployed population (as % of total labor force ages 15-24) in Hungary in 2005 to that in 2007?
Make the answer very short. 1.07. What is the ratio of the Unemployed population (as % of total labor force ages 15-24) of Armenia in 2005 to that in 2008?
Your answer should be very brief. 1.53. What is the ratio of the Unemployed population (as % of total labor force ages 15-24) in Bahamas in 2005 to that in 2008?
Ensure brevity in your answer.  1.12. What is the ratio of the Unemployed population (as % of total labor force ages 15-24) in Hungary in 2005 to that in 2008?
Your response must be concise. 0.98. What is the ratio of the Unemployed population (as % of total labor force ages 15-24) in Armenia in 2005 to that in 2009?
Make the answer very short. 1.38. What is the ratio of the Unemployed population (as % of total labor force ages 15-24) of Bahamas in 2005 to that in 2009?
Ensure brevity in your answer.  0.56. What is the ratio of the Unemployed population (as % of total labor force ages 15-24) in Hungary in 2005 to that in 2009?
Offer a very short reply. 0.73. What is the ratio of the Unemployed population (as % of total labor force ages 15-24) in Armenia in 2006 to that in 2007?
Provide a short and direct response. 0.95. What is the ratio of the Unemployed population (as % of total labor force ages 15-24) in Bahamas in 2006 to that in 2007?
Offer a terse response. 0.83. What is the ratio of the Unemployed population (as % of total labor force ages 15-24) in Hungary in 2006 to that in 2007?
Keep it short and to the point. 1.05. What is the ratio of the Unemployed population (as % of total labor force ages 15-24) of Armenia in 2006 to that in 2008?
Your answer should be compact. 1.53. What is the ratio of the Unemployed population (as % of total labor force ages 15-24) in Bahamas in 2006 to that in 2008?
Offer a very short reply. 0.87. What is the ratio of the Unemployed population (as % of total labor force ages 15-24) of Hungary in 2006 to that in 2008?
Keep it short and to the point. 0.97. What is the ratio of the Unemployed population (as % of total labor force ages 15-24) of Armenia in 2006 to that in 2009?
Offer a very short reply. 1.38. What is the ratio of the Unemployed population (as % of total labor force ages 15-24) in Bahamas in 2006 to that in 2009?
Your response must be concise. 0.44. What is the ratio of the Unemployed population (as % of total labor force ages 15-24) of Hungary in 2006 to that in 2009?
Offer a terse response. 0.73. What is the ratio of the Unemployed population (as % of total labor force ages 15-24) in Armenia in 2007 to that in 2008?
Keep it short and to the point. 1.61. What is the ratio of the Unemployed population (as % of total labor force ages 15-24) in Bahamas in 2007 to that in 2008?
Offer a terse response. 1.05. What is the ratio of the Unemployed population (as % of total labor force ages 15-24) of Hungary in 2007 to that in 2008?
Ensure brevity in your answer.  0.92. What is the ratio of the Unemployed population (as % of total labor force ages 15-24) in Armenia in 2007 to that in 2009?
Your answer should be very brief. 1.45. What is the ratio of the Unemployed population (as % of total labor force ages 15-24) of Bahamas in 2007 to that in 2009?
Your answer should be very brief. 0.53. What is the ratio of the Unemployed population (as % of total labor force ages 15-24) of Hungary in 2007 to that in 2009?
Give a very brief answer. 0.69. What is the ratio of the Unemployed population (as % of total labor force ages 15-24) of Armenia in 2008 to that in 2009?
Keep it short and to the point. 0.9. What is the ratio of the Unemployed population (as % of total labor force ages 15-24) in Bahamas in 2008 to that in 2009?
Offer a very short reply. 0.5. What is the ratio of the Unemployed population (as % of total labor force ages 15-24) of Hungary in 2008 to that in 2009?
Keep it short and to the point. 0.75. What is the difference between the highest and the second highest Unemployed population (as % of total labor force ages 15-24) of Hungary?
Your answer should be very brief. 6.7. What is the difference between the highest and the lowest Unemployed population (as % of total labor force ages 15-24) of Armenia?
Give a very brief answer. 22.1. What is the difference between the highest and the lowest Unemployed population (as % of total labor force ages 15-24) in Bahamas?
Your answer should be very brief. 20.2. What is the difference between the highest and the lowest Unemployed population (as % of total labor force ages 15-24) in Hungary?
Ensure brevity in your answer.  14. 